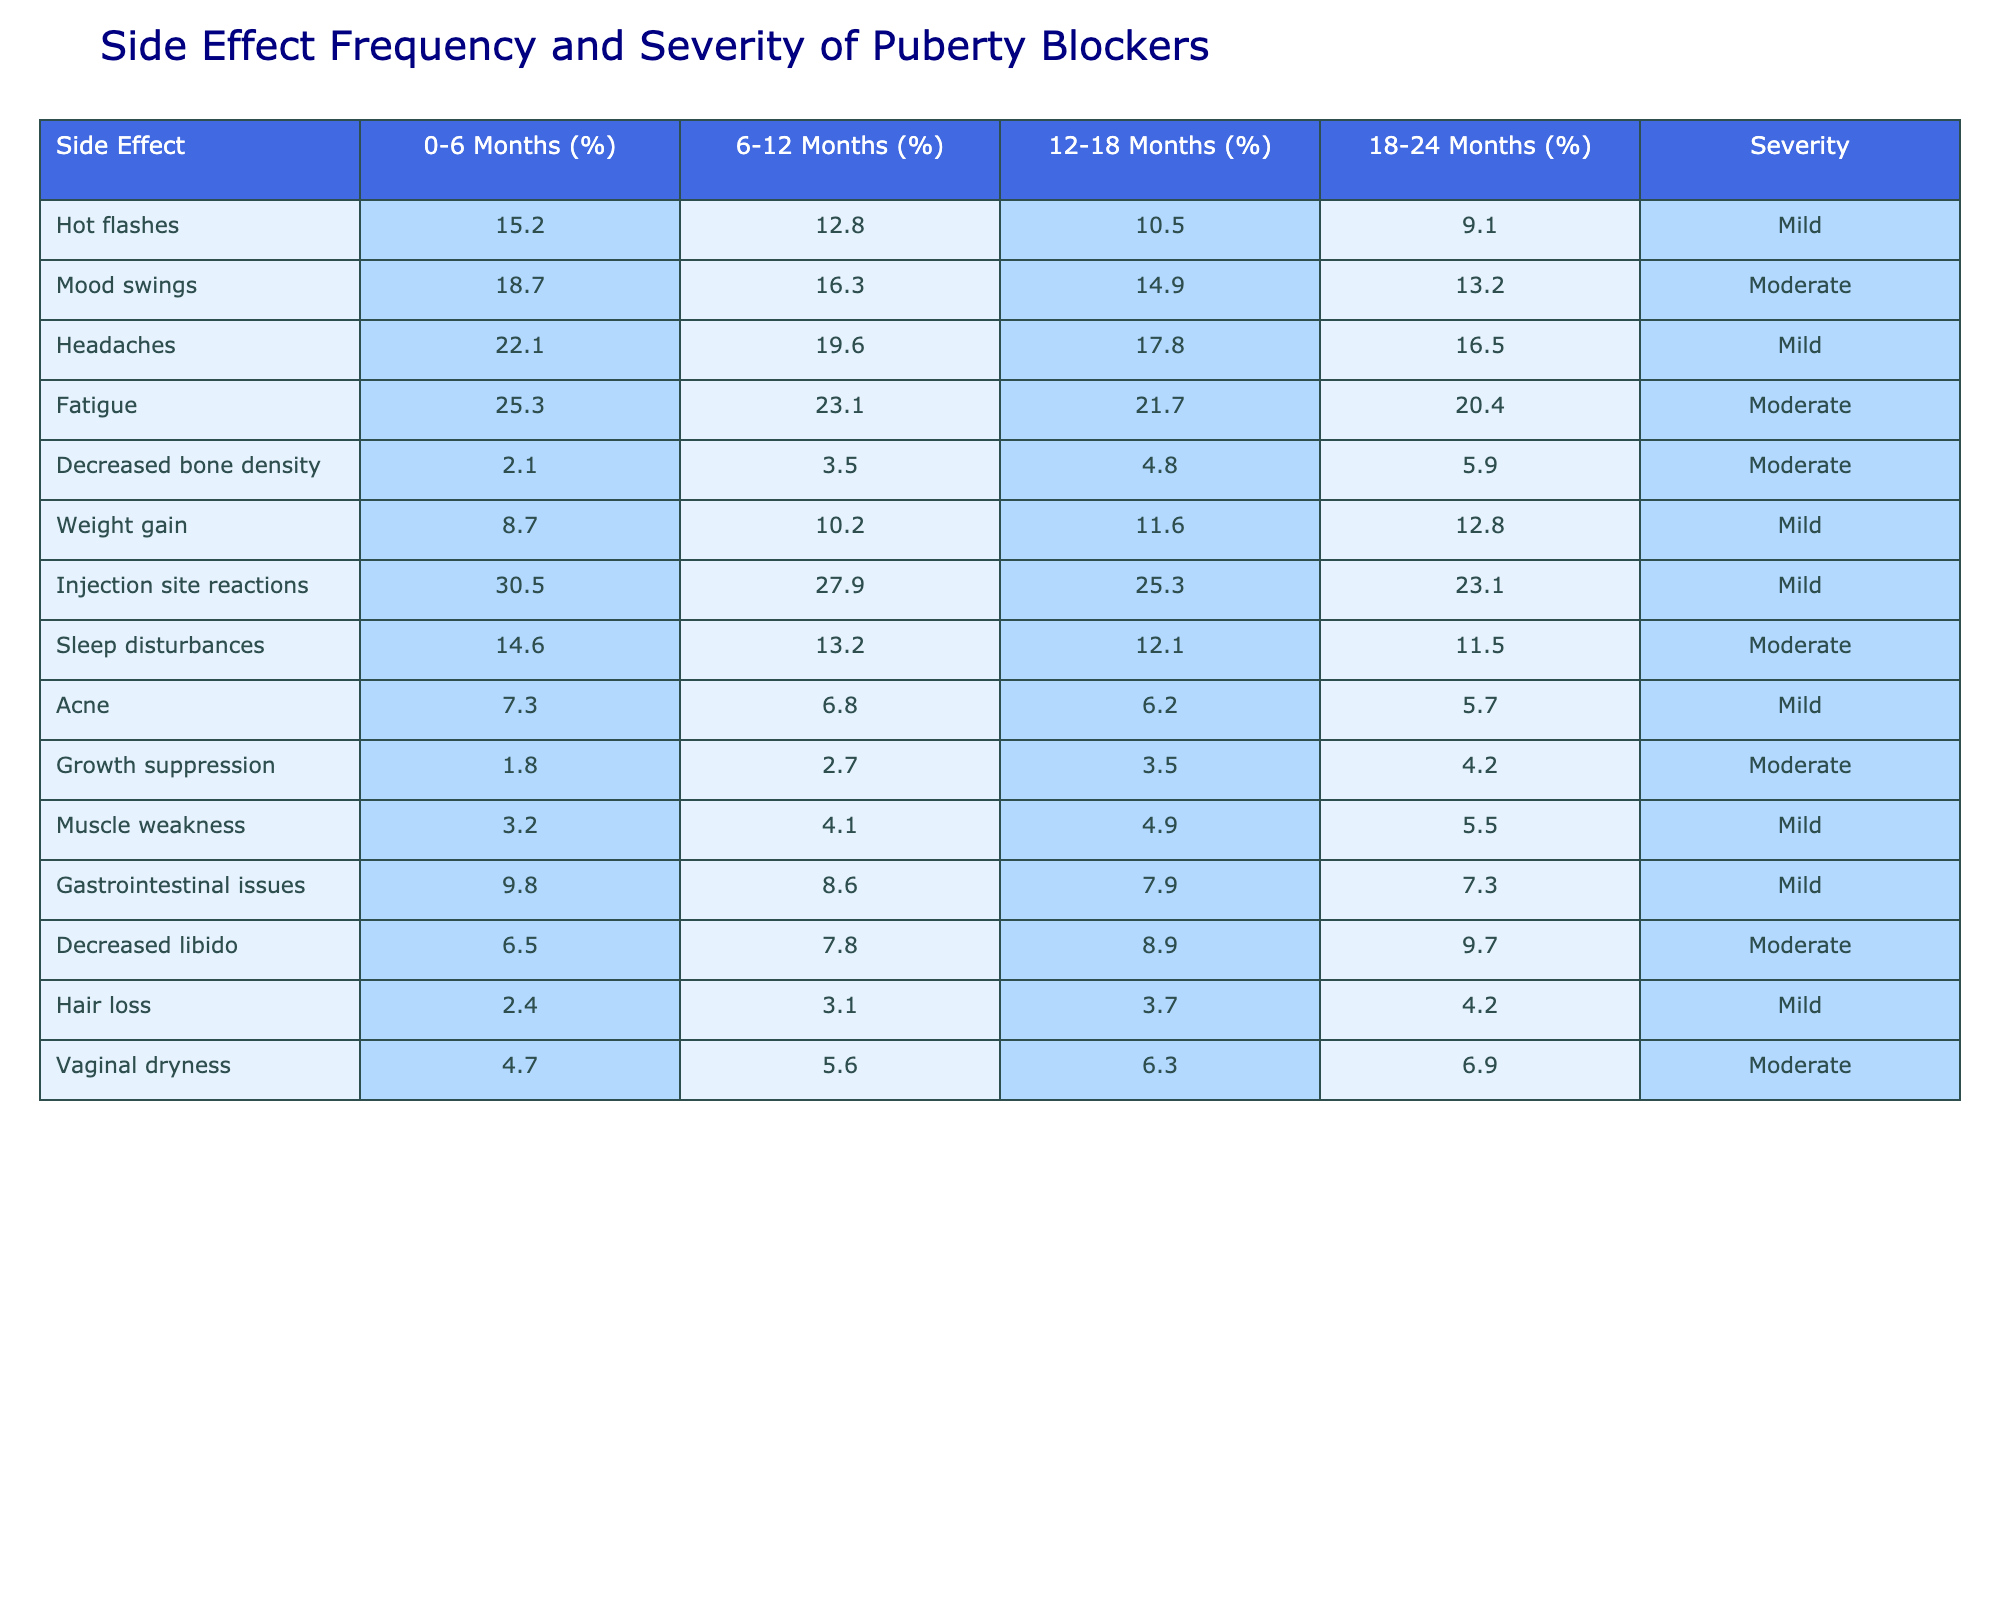What is the percentage of adolescents who reported headaches at 0-6 months? According to the table, the percentage of adolescents reporting headaches at 0-6 months is directly listed as 22.1%.
Answer: 22.1% Which side effect has the highest percentage at 6-12 months? By examining the values for 6-12 months, injection site reactions are at 27.9%, which is the highest compared to other side effects listed.
Answer: Injection site reactions What is the percentage change in mood swings from 0-6 months to 18-24 months? The percentage of mood swings at 0-6 months is 18.7%, and at 18-24 months, it is 13.2%. The change is calculated as 18.7% - 13.2% = 5.5%.
Answer: 5.5% Does the frequency of weight gain increase or decrease over the 2-year period? The percentages for weight gain are 8.7% at 0-6 months, 10.2% at 6-12 months, 11.6% at 12-18 months, and 12.8% at 18-24 months. The data shows an increasing trend.
Answer: Yes What is the average percentage of adolescents experiencing fatigue over the four intervals? The percentages are 25.3%, 23.1%, 21.7%, and 20.4%. To find the average: (25.3 + 23.1 + 21.7 + 20.4) / 4 = 22.625%.
Answer: 22.625% Which side effect shows the most significant decrease in percentage from 0-6 months to 18-24 months? Hot flashes decreased from 15.2% to 9.1%, which is a decrease of 6.1%. Comparing all side effects, this shows the most significant decrease.
Answer: Hot flashes What is the relationship between the severity of side effects and the frequency of occurrence? Most side effects listed as mild generally have a lower percentage than those categorized as moderate. For example, headaches (mild, 22.1%) show a greater frequency than decreased libido (moderate, 6.5%).
Answer: Moderate side effects tend to have lower frequencies How many side effects are reported with moderate severity at the 18-24 month interval? At the 18-24 month interval, the side effects that are moderate include mood swings (13.2%), fatigue (20.4%), decreased bone density (5.9%), sleep disturbances (11.5%), decreased libido (9.7%), growth suppression (4.2%), and vaginal dryness (6.9%). Counting these gives a total of 7 side effects.
Answer: 7 Is there a side effect that remains constant over the 2 years? Reviewing the data, none of the side effects have constant values over the 2 years. Each side effect shows some variation during the intervals.
Answer: No 